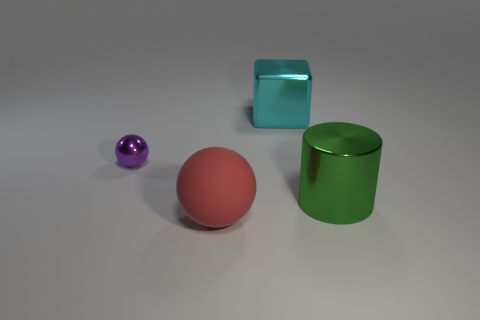Subtract all gray blocks. Subtract all purple spheres. How many blocks are left? 1 Add 2 blue metal objects. How many objects exist? 6 Subtract all cylinders. How many objects are left? 3 Add 2 cyan things. How many cyan things are left? 3 Add 3 cyan metal objects. How many cyan metal objects exist? 4 Subtract 0 blue spheres. How many objects are left? 4 Subtract all matte blocks. Subtract all metallic cylinders. How many objects are left? 3 